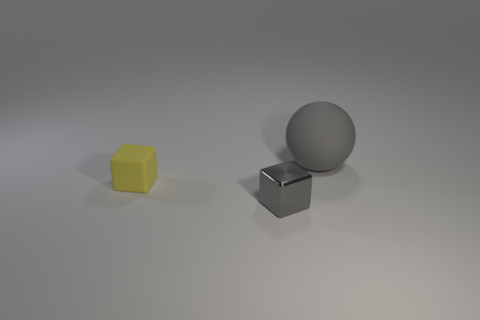Add 1 gray things. How many objects exist? 4 Subtract all blocks. How many objects are left? 1 Add 1 cyan cylinders. How many cyan cylinders exist? 1 Subtract 0 cyan cylinders. How many objects are left? 3 Subtract all yellow matte blocks. Subtract all gray shiny objects. How many objects are left? 1 Add 2 gray blocks. How many gray blocks are left? 3 